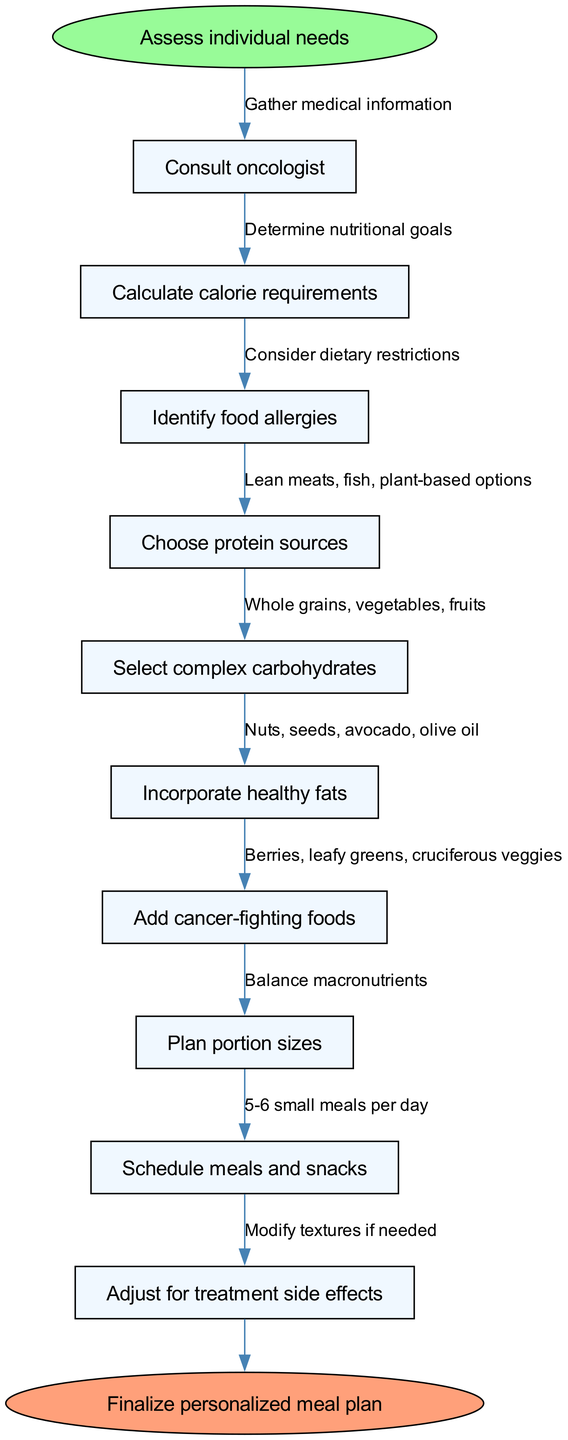What is the start node in the flow chart? The start node is clearly identified at the top of the flow chart, labeled as "Assess individual needs." This is the point from which the flow of the meal planning process begins.
Answer: Assess individual needs How many nodes are in the flow chart? By counting the nodes listed in the data provided, there is a total of 10 nodes, including the start and end nodes. This is done by identifying each step in the process leading to the final meal plan.
Answer: 10 What is the end node labeled as? The end node, located at the bottom of the flow chart, is labeled "Finalize personalized meal plan." This indicates the conclusion of the meal planning process.
Answer: Finalize personalized meal plan Which node comes after "Identify food allergies"? In the sequence of nodes established by the flow chart, the node that follows "Identify food allergies" is "Choose protein sources.” The flow indicates this step comes next in the process.
Answer: Choose protein sources What dietary restriction is considered before choosing protein sources? The flow chart indicates that dietary restrictions related to food allergies must be considered prior to selecting protein sources. This relationship is explicitly stated as part of the planning steps.
Answer: Consider dietary restrictions How should meal sizes be planned according to the flow chart? The diagram specifies that meal sizes should be planned with "5-6 small meals per day." This is indicated by the corresponding edge leading to that particular node in the flow.
Answer: 5-6 small meals per day Which foods are recommended for incorporating healthy fats? According to the flow chart, the recommended foods for healthy fats include "Nuts, seeds, avocado, olive oil." This specific information is represented within the corresponding node.
Answer: Nuts, seeds, avocado, olive oil What is the relationship between "Add cancer-fighting foods" and "Incorporate healthy fats"? The flow chart shows that "Add cancer-fighting foods" comes after "Incorporate healthy fats." This illustrates the order in which these steps should be completed, indicating cancer-fighting foods are addressed subsequently.
Answer: Sequential order What step should be taken before finalizing the meal plan? Before finalizing the meal plan, the flow chart suggests that it is essential to "Adjust for treatment side effects." This is the last preparatory action indicated before reaching the final step.
Answer: Adjust for treatment side effects 